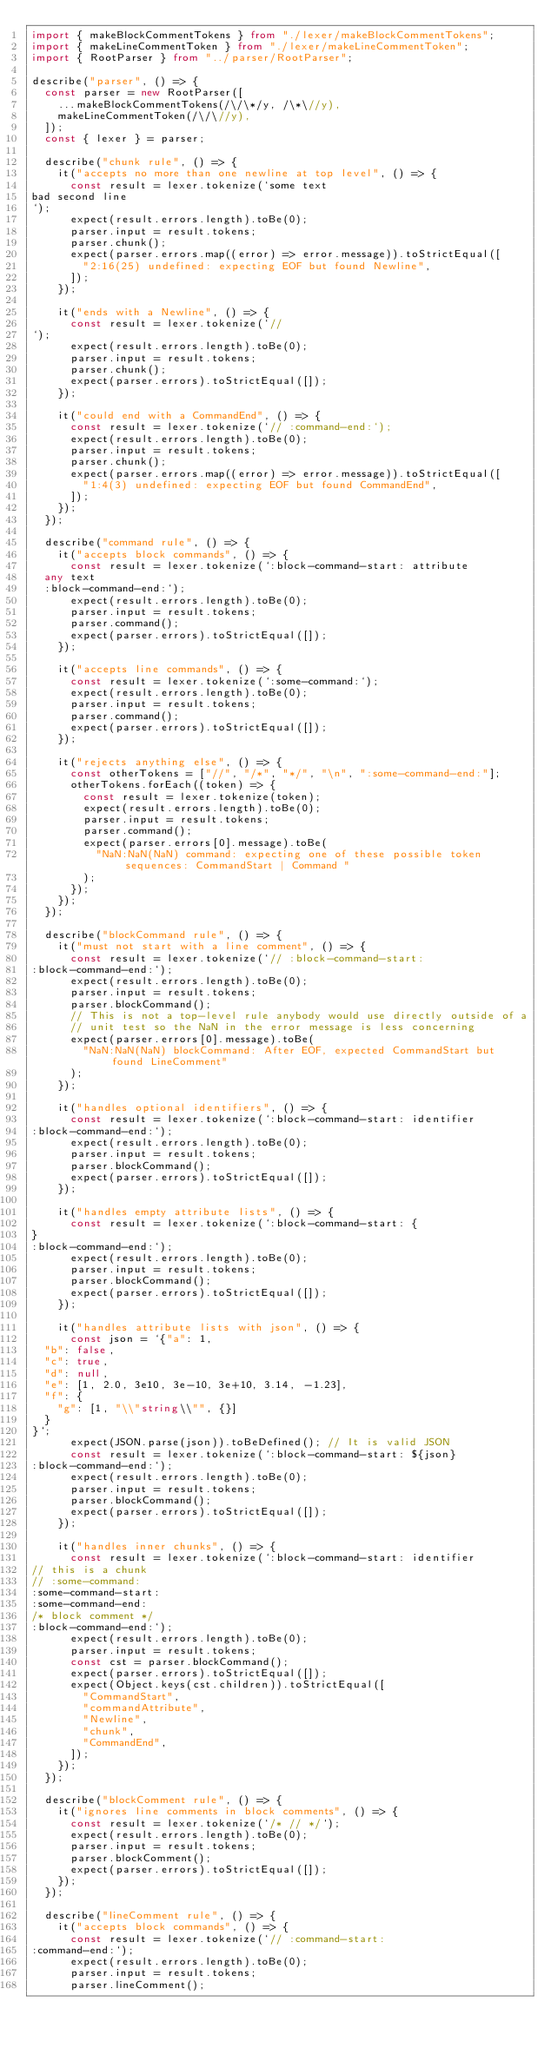<code> <loc_0><loc_0><loc_500><loc_500><_TypeScript_>import { makeBlockCommentTokens } from "./lexer/makeBlockCommentTokens";
import { makeLineCommentToken } from "./lexer/makeLineCommentToken";
import { RootParser } from "../parser/RootParser";

describe("parser", () => {
  const parser = new RootParser([
    ...makeBlockCommentTokens(/\/\*/y, /\*\//y),
    makeLineCommentToken(/\/\//y),
  ]);
  const { lexer } = parser;

  describe("chunk rule", () => {
    it("accepts no more than one newline at top level", () => {
      const result = lexer.tokenize(`some text
bad second line
`);
      expect(result.errors.length).toBe(0);
      parser.input = result.tokens;
      parser.chunk();
      expect(parser.errors.map((error) => error.message)).toStrictEqual([
        "2:16(25) undefined: expecting EOF but found Newline",
      ]);
    });

    it("ends with a Newline", () => {
      const result = lexer.tokenize(`//
`);
      expect(result.errors.length).toBe(0);
      parser.input = result.tokens;
      parser.chunk();
      expect(parser.errors).toStrictEqual([]);
    });

    it("could end with a CommandEnd", () => {
      const result = lexer.tokenize(`// :command-end:`);
      expect(result.errors.length).toBe(0);
      parser.input = result.tokens;
      parser.chunk();
      expect(parser.errors.map((error) => error.message)).toStrictEqual([
        "1:4(3) undefined: expecting EOF but found CommandEnd",
      ]);
    });
  });

  describe("command rule", () => {
    it("accepts block commands", () => {
      const result = lexer.tokenize(`:block-command-start: attribute
  any text
  :block-command-end:`);
      expect(result.errors.length).toBe(0);
      parser.input = result.tokens;
      parser.command();
      expect(parser.errors).toStrictEqual([]);
    });

    it("accepts line commands", () => {
      const result = lexer.tokenize(`:some-command:`);
      expect(result.errors.length).toBe(0);
      parser.input = result.tokens;
      parser.command();
      expect(parser.errors).toStrictEqual([]);
    });

    it("rejects anything else", () => {
      const otherTokens = ["//", "/*", "*/", "\n", ":some-command-end:"];
      otherTokens.forEach((token) => {
        const result = lexer.tokenize(token);
        expect(result.errors.length).toBe(0);
        parser.input = result.tokens;
        parser.command();
        expect(parser.errors[0].message).toBe(
          "NaN:NaN(NaN) command: expecting one of these possible token sequences: CommandStart | Command "
        );
      });
    });
  });

  describe("blockCommand rule", () => {
    it("must not start with a line comment", () => {
      const result = lexer.tokenize(`// :block-command-start:
:block-command-end:`);
      expect(result.errors.length).toBe(0);
      parser.input = result.tokens;
      parser.blockCommand();
      // This is not a top-level rule anybody would use directly outside of a
      // unit test so the NaN in the error message is less concerning
      expect(parser.errors[0].message).toBe(
        "NaN:NaN(NaN) blockCommand: After EOF, expected CommandStart but found LineComment"
      );
    });

    it("handles optional identifiers", () => {
      const result = lexer.tokenize(`:block-command-start: identifier
:block-command-end:`);
      expect(result.errors.length).toBe(0);
      parser.input = result.tokens;
      parser.blockCommand();
      expect(parser.errors).toStrictEqual([]);
    });

    it("handles empty attribute lists", () => {
      const result = lexer.tokenize(`:block-command-start: {
}
:block-command-end:`);
      expect(result.errors.length).toBe(0);
      parser.input = result.tokens;
      parser.blockCommand();
      expect(parser.errors).toStrictEqual([]);
    });

    it("handles attribute lists with json", () => {
      const json = `{"a": 1,
  "b": false,
  "c": true,
  "d": null,
  "e": [1, 2.0, 3e10, 3e-10, 3e+10, 3.14, -1.23],
  "f": {
    "g": [1, "\\"string\\"", {}]
  }
}`;
      expect(JSON.parse(json)).toBeDefined(); // It is valid JSON
      const result = lexer.tokenize(`:block-command-start: ${json}
:block-command-end:`);
      expect(result.errors.length).toBe(0);
      parser.input = result.tokens;
      parser.blockCommand();
      expect(parser.errors).toStrictEqual([]);
    });

    it("handles inner chunks", () => {
      const result = lexer.tokenize(`:block-command-start: identifier
// this is a chunk
// :some-command:
:some-command-start:
:some-command-end:
/* block comment */
:block-command-end:`);
      expect(result.errors.length).toBe(0);
      parser.input = result.tokens;
      const cst = parser.blockCommand();
      expect(parser.errors).toStrictEqual([]);
      expect(Object.keys(cst.children)).toStrictEqual([
        "CommandStart",
        "commandAttribute",
        "Newline",
        "chunk",
        "CommandEnd",
      ]);
    });
  });

  describe("blockComment rule", () => {
    it("ignores line comments in block comments", () => {
      const result = lexer.tokenize(`/* // */`);
      expect(result.errors.length).toBe(0);
      parser.input = result.tokens;
      parser.blockComment();
      expect(parser.errors).toStrictEqual([]);
    });
  });

  describe("lineComment rule", () => {
    it("accepts block commands", () => {
      const result = lexer.tokenize(`// :command-start:
:command-end:`);
      expect(result.errors.length).toBe(0);
      parser.input = result.tokens;
      parser.lineComment();</code> 